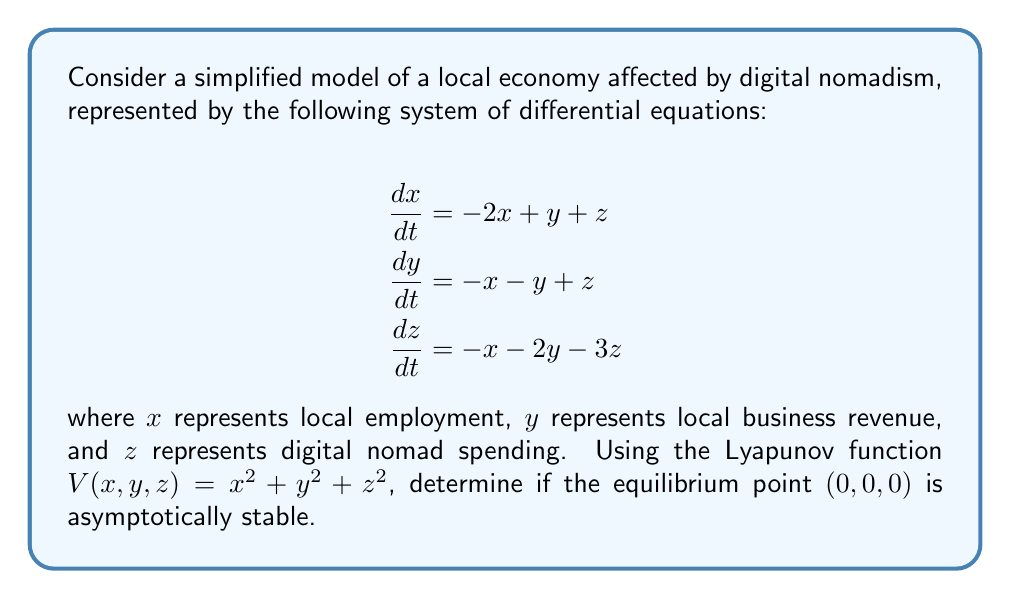Provide a solution to this math problem. To determine the stability of the equilibrium point using Lyapunov's direct method, we need to follow these steps:

1. Calculate the time derivative of the Lyapunov function $V(x,y,z)$:

$$\frac{dV}{dt} = 2x\frac{dx}{dt} + 2y\frac{dy}{dt} + 2z\frac{dz}{dt}$$

2. Substitute the expressions for $\frac{dx}{dt}$, $\frac{dy}{dt}$, and $\frac{dz}{dt}$ from the given system:

$$\begin{align}
\frac{dV}{dt} &= 2x(-2x + y + z) + 2y(-x - y + z) + 2z(-x - 2y - 3z) \\
&= -4x^2 + 2xy + 2xz - 2xy - 2y^2 + 2yz - 2xz - 4yz - 6z^2 \\
&= -4x^2 - 2y^2 - 6z^2 - 2yz
\end{align}$$

3. Analyze the sign of $\frac{dV}{dt}$:

The function $\frac{dV}{dt}$ is negative definite if it is strictly less than zero for all non-zero values of $x$, $y$, and $z$. We can see that the first three terms $(-4x^2 - 2y^2 - 6z^2)$ are always negative or zero. The last term $(-2yz)$ can be positive, negative, or zero depending on the values of $y$ and $z$.

To prove that $\frac{dV}{dt}$ is negative definite, we need to show that:

$$-4x^2 - 2y^2 - 6z^2 - 2yz < 0$$

for all non-zero $(x,y,z)$.

We can rewrite this as:

$$-4x^2 - 2(y^2 + 2yz + z^2) - 4z^2 < 0$$

$$-4x^2 - 2(y + z)^2 - 4z^2 < 0$$

This inequality always holds for non-zero $(x,y,z)$ because each term is non-positive, and at least one term will be strictly negative for any non-zero point.

4. Conclude about stability:

Since $V(x,y,z)$ is positive definite and $\frac{dV}{dt}$ is negative definite, we can conclude by Lyapunov's direct method that the equilibrium point $(0,0,0)$ is asymptotically stable.
Answer: The equilibrium point $(0,0,0)$ is asymptotically stable. 